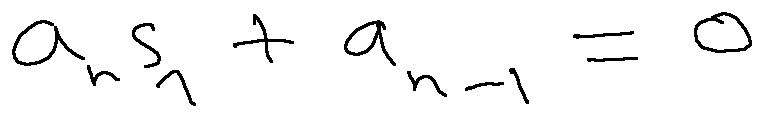Convert formula to latex. <formula><loc_0><loc_0><loc_500><loc_500>a _ { n } s _ { 1 } + a _ { n - 1 } = 0</formula> 